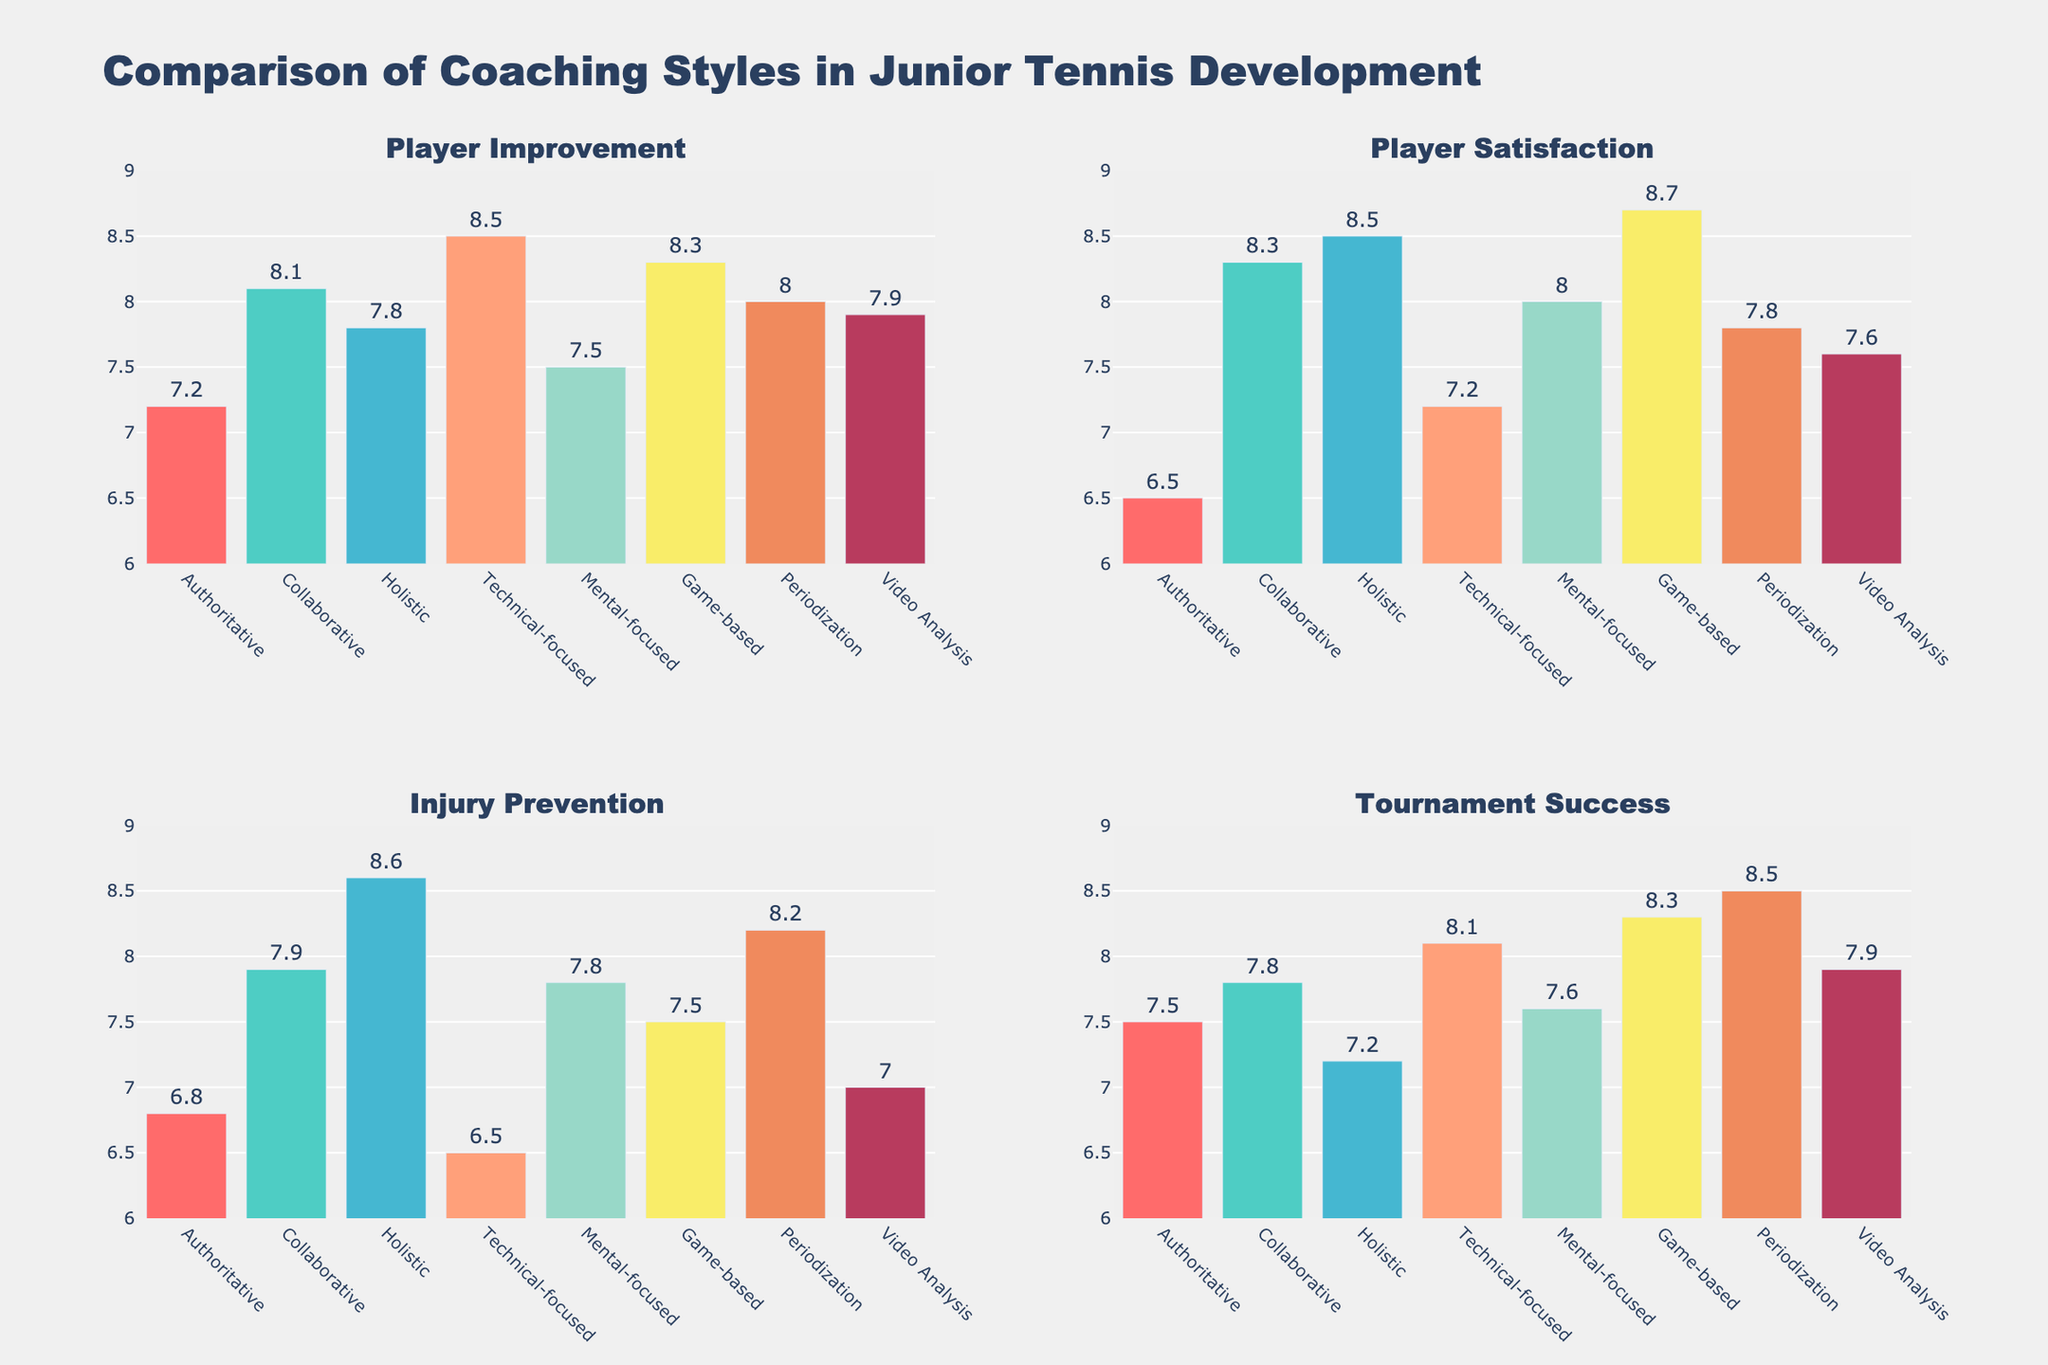What's the title of the figure? The title is usually at the top of the figure and provides a summary of its content. Here, the title is "Comparison of Coaching Styles in Junior Tennis Development."
Answer: Comparison of Coaching Styles in Junior Tennis Development How many subplots are in the figure? The figure is divided into smaller plots called subplots. We can visually count that there are four subplots in the grid.
Answer: Four Which coaching style has the highest player satisfaction? In the "Player Satisfaction" subplot, look for the highest bar. The Holistic style shows the highest player satisfaction with a value of 8.5.
Answer: Holistic What is the player improvement value for the Technical-focused coaching style? Focus on the "Player Improvement" subplot and locate the bar for the Technical-focused style. The height of this bar reaches 8.5.
Answer: 8.5 Compare the injury prevention values of Collaborative and Game-based coaching styles. Which one is higher? Locate the "Injury Prevention" subplot and compare the heights of the bars for both Collaborative and Game-based styles. The Collaborative style has a higher value (7.9) compared to the Game-based style (7.5).
Answer: Collaborative Which coaching style shows the lowest tournament success? In the "Tournament Success" subplot, find the shortest bar. The Holistic style has the lowest tournament success with a value of 7.2.
Answer: Holistic What is the difference in player improvement between the Authoritative and Ment-focused coaching styles? Locate the "Player Improvement" subplot. The values are Authoritative (7.2) and Mental-focused (7.5). The difference is calculated as 7.5 - 7.2 = 0.3.
Answer: 0.3 Which coaching style has equal values for player satisfaction and injury prevention? Examine the "Player Satisfaction" and "Injury Prevention" subplots to identify any bars with equal heights. The Holistic style has equal values for these metrics, both being 8.5.
Answer: Holistic What's the average value of player improvement across all coaching styles? Sum up all the player improvement values (7.2 + 8.1 + 7.8 + 8.5 + 7.5 + 8.3 + 8.0 + 7.9) = 63.3. Since there are 8 coaching styles, the average is 63.3 / 8 = 7.9125.
Answer: 7.91 Which coaching style has the most balanced performance across all four metrics? To determine the most balanced performance, look for a coaching style with relatively consistent bar heights across "Player Improvement," "Player Satisfaction," "Injury Prevention," and "Tournament Success." The Periodization style has consistent values: 8.0, 7.8, 8.2, and 8.5, which indicate a more balanced performance across metrics.
Answer: Periodization 